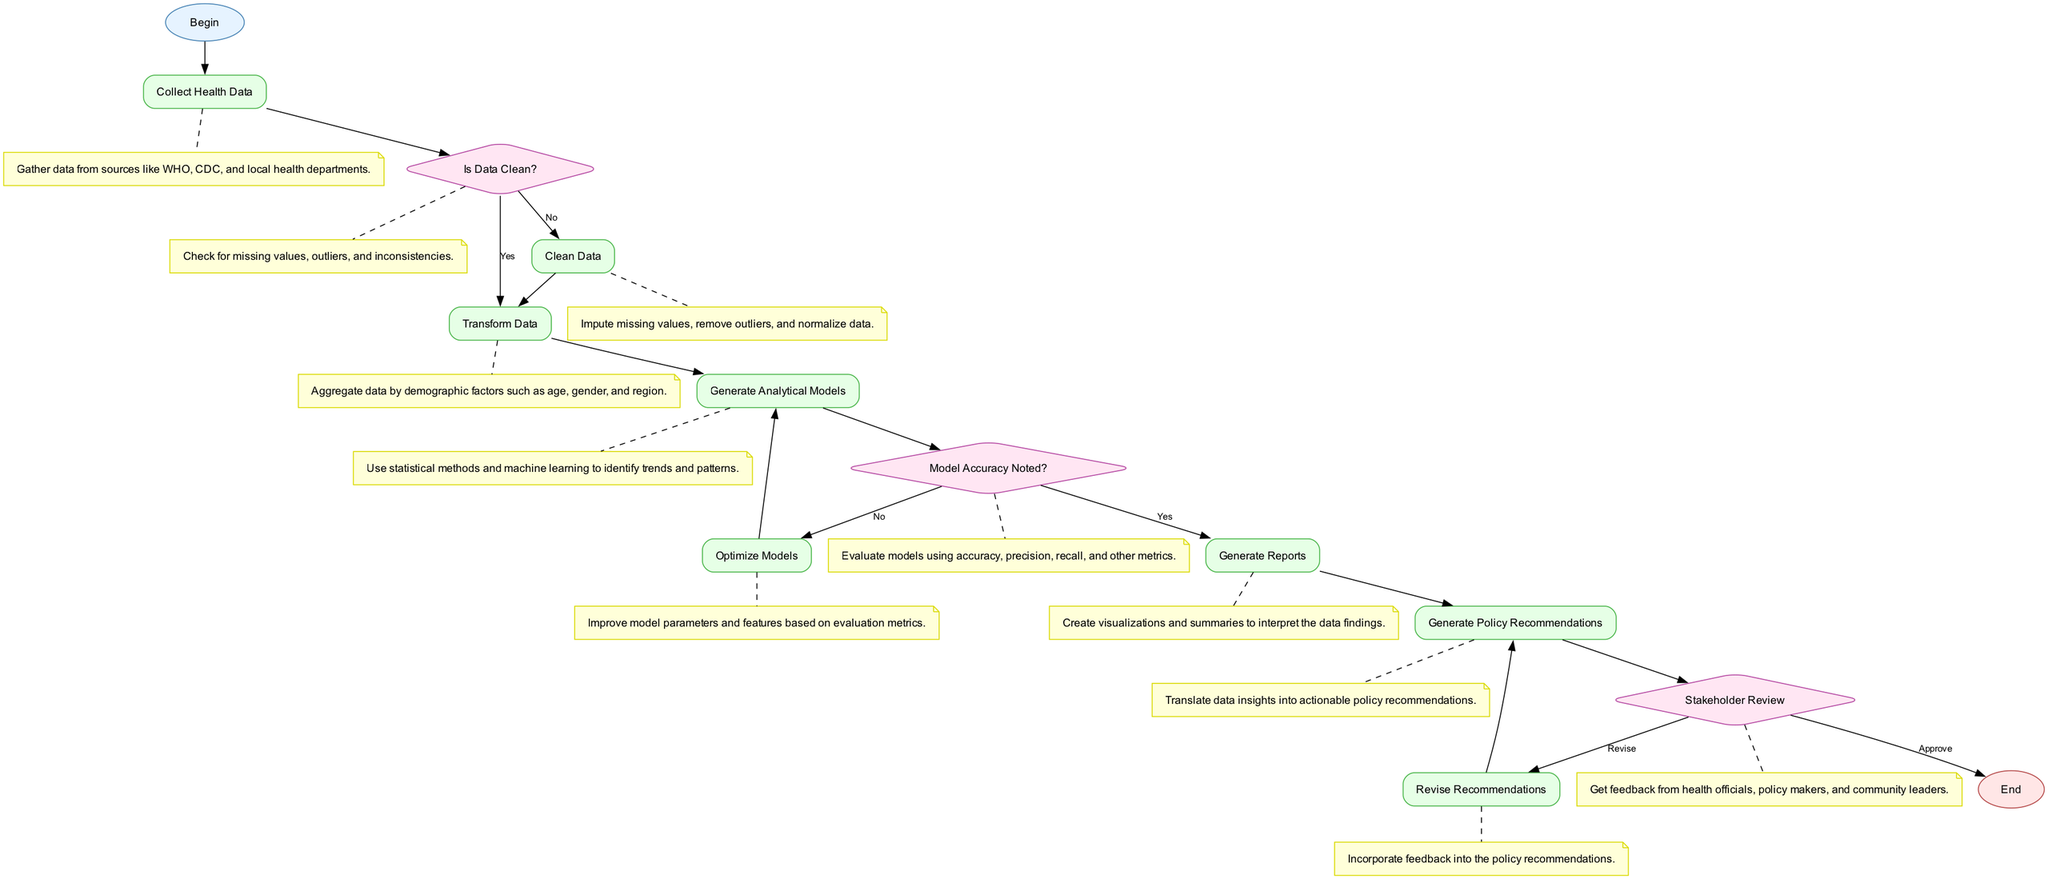What is the first step in the flowchart? The flowchart begins with the node labeled "Begin", which indicates the starting point of the process for developing the policy impact analysis tool.
Answer: Begin How many process nodes are there in the flowchart? The flowchart includes five process nodes: "Collect Health Data", "Clean Data", "Transform Data", "Generate Analytical Models", "Generate Reports", and "Generate Policy Recommendations".
Answer: Five What happens if the data is clean? If the data is clean, the flow continues to the "Transform Data" node, bypassing the "Clean Data" process node.
Answer: Goes to Transform Data What is evaluated after generating analytical models? After generating analytical models, the next step is to evaluate whether the "Model Accuracy Noted?" to ensure the model meets necessary criteria.
Answer: Model Accuracy Noted What is done if the stakeholder review results in "Revise"? If the stakeholder review results in "Revise", the flowchart indicates that the recommendation revision process begins, leading back to an earlier step where recommendations are modified.
Answer: Revise Recommendations How many decision nodes are present in the flowchart? The flowchart contains three decision nodes: "Is Data Clean?", "Model Accuracy Noted?", and "Stakeholder Review".
Answer: Three What is the final step in the flowchart? The final step in the flowchart, indicated as the endpoint of the process, is labeled "End".
Answer: End What do we do with data insights after generating reports? After generating reports, the data insights are translated into actionable policy recommendations.
Answer: Generate Policy Recommendations What should be done if model accuracy is not noted? If model accuracy is not noted, the flowchart specifies that the next step is to "Optimize Models" to improve them before reevaluation.
Answer: Optimize Models 